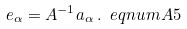<formula> <loc_0><loc_0><loc_500><loc_500>e _ { \alpha } = A ^ { - 1 } a _ { \alpha } \, . \ e q n u m { A 5 }</formula> 